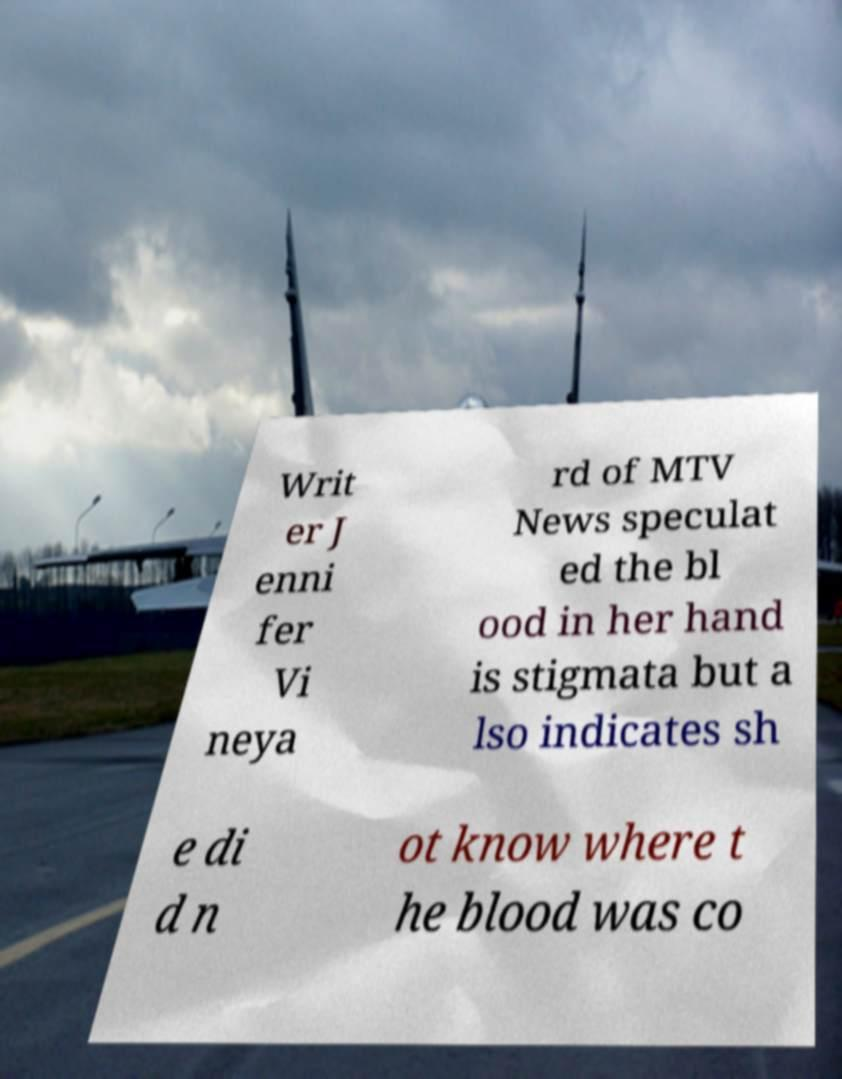Can you read and provide the text displayed in the image?This photo seems to have some interesting text. Can you extract and type it out for me? Writ er J enni fer Vi neya rd of MTV News speculat ed the bl ood in her hand is stigmata but a lso indicates sh e di d n ot know where t he blood was co 